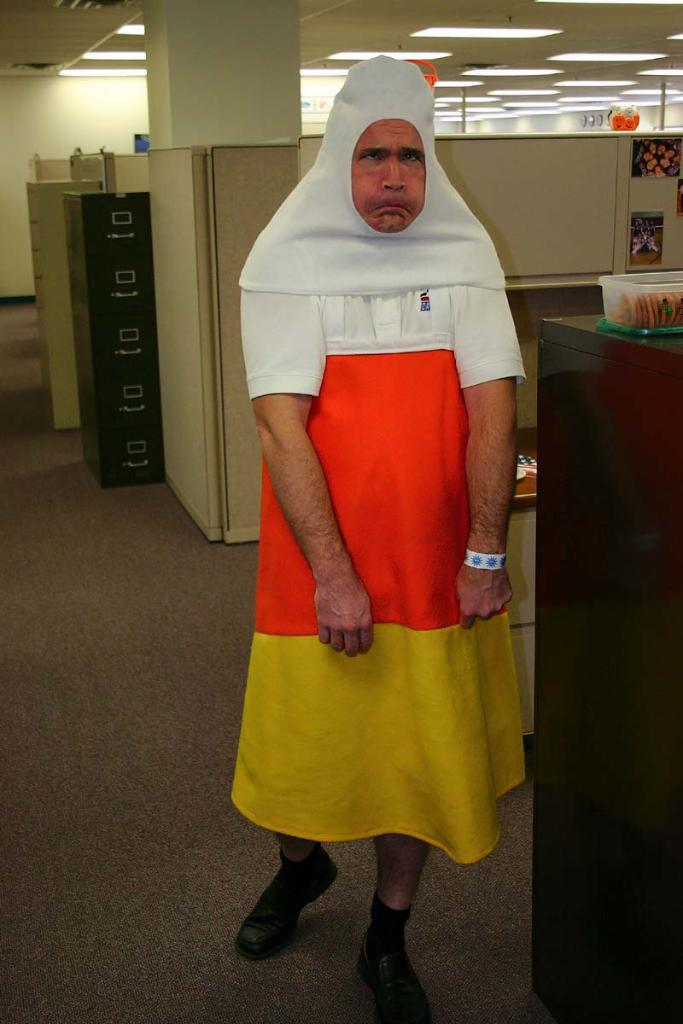What is the main subject in the image? There is a person standing in the image. What type of furniture can be seen in the image? There are black color desks in the image. What architectural feature is present in the image? There is a pillar in the image. What part of the building is visible in the image? The roof is visible in the image. What is used for illumination in the image? There are lights in the image. Can you see any cracks in the roof in the image? There is no mention of any cracks in the roof in the provided facts, so we cannot determine if there are any cracks present. 